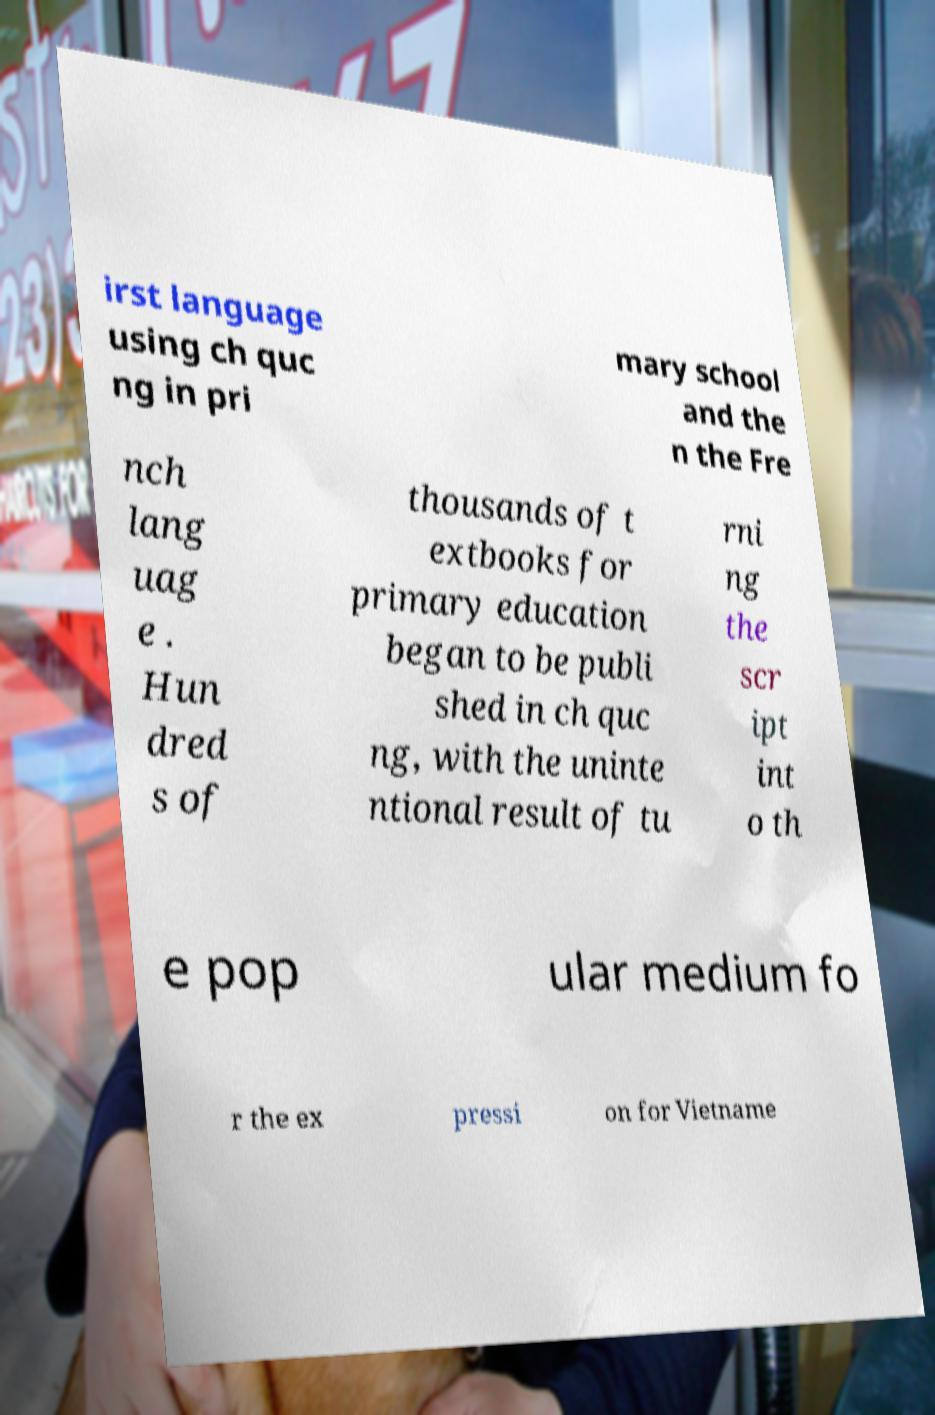Could you assist in decoding the text presented in this image and type it out clearly? irst language using ch quc ng in pri mary school and the n the Fre nch lang uag e . Hun dred s of thousands of t extbooks for primary education began to be publi shed in ch quc ng, with the uninte ntional result of tu rni ng the scr ipt int o th e pop ular medium fo r the ex pressi on for Vietname 